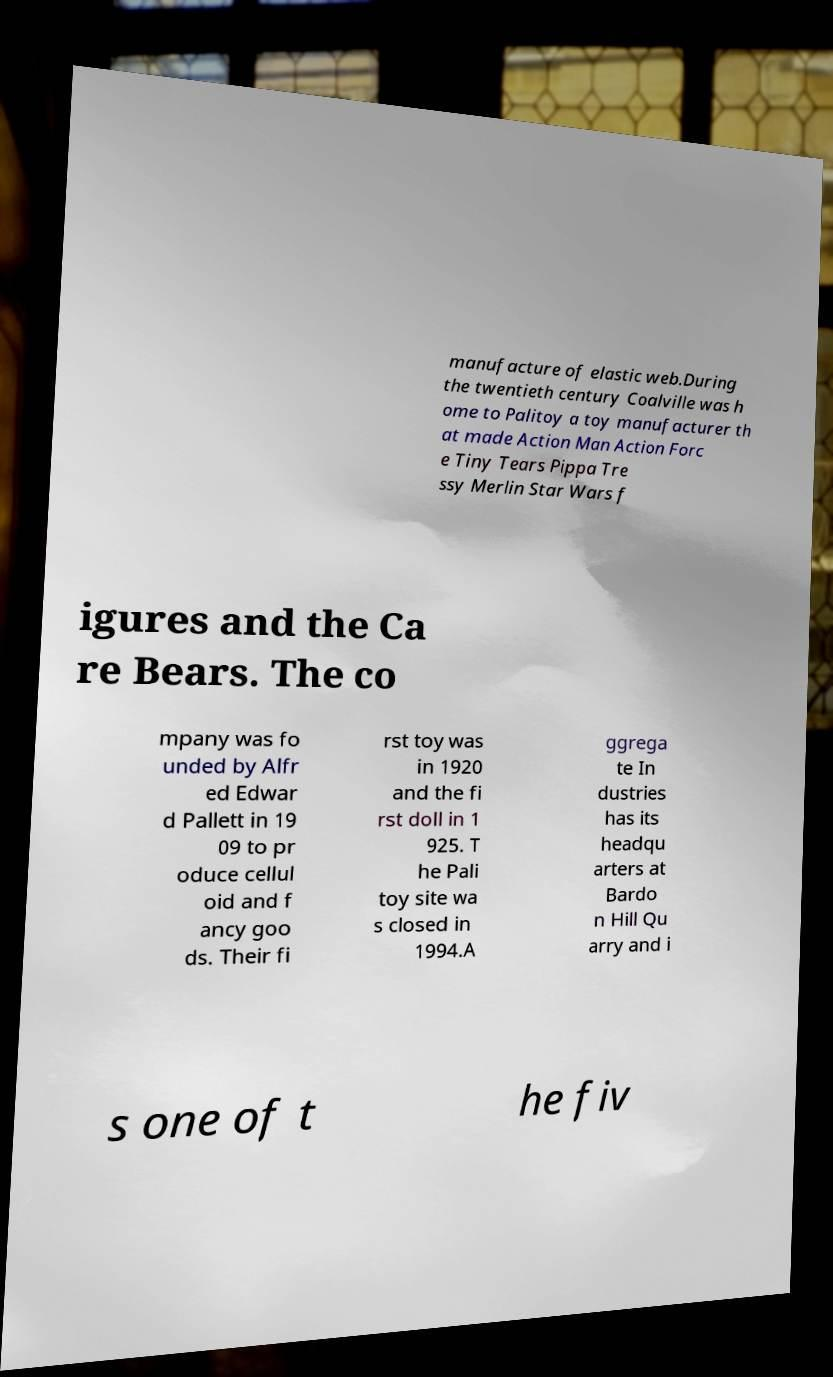Please identify and transcribe the text found in this image. manufacture of elastic web.During the twentieth century Coalville was h ome to Palitoy a toy manufacturer th at made Action Man Action Forc e Tiny Tears Pippa Tre ssy Merlin Star Wars f igures and the Ca re Bears. The co mpany was fo unded by Alfr ed Edwar d Pallett in 19 09 to pr oduce cellul oid and f ancy goo ds. Their fi rst toy was in 1920 and the fi rst doll in 1 925. T he Pali toy site wa s closed in 1994.A ggrega te In dustries has its headqu arters at Bardo n Hill Qu arry and i s one of t he fiv 